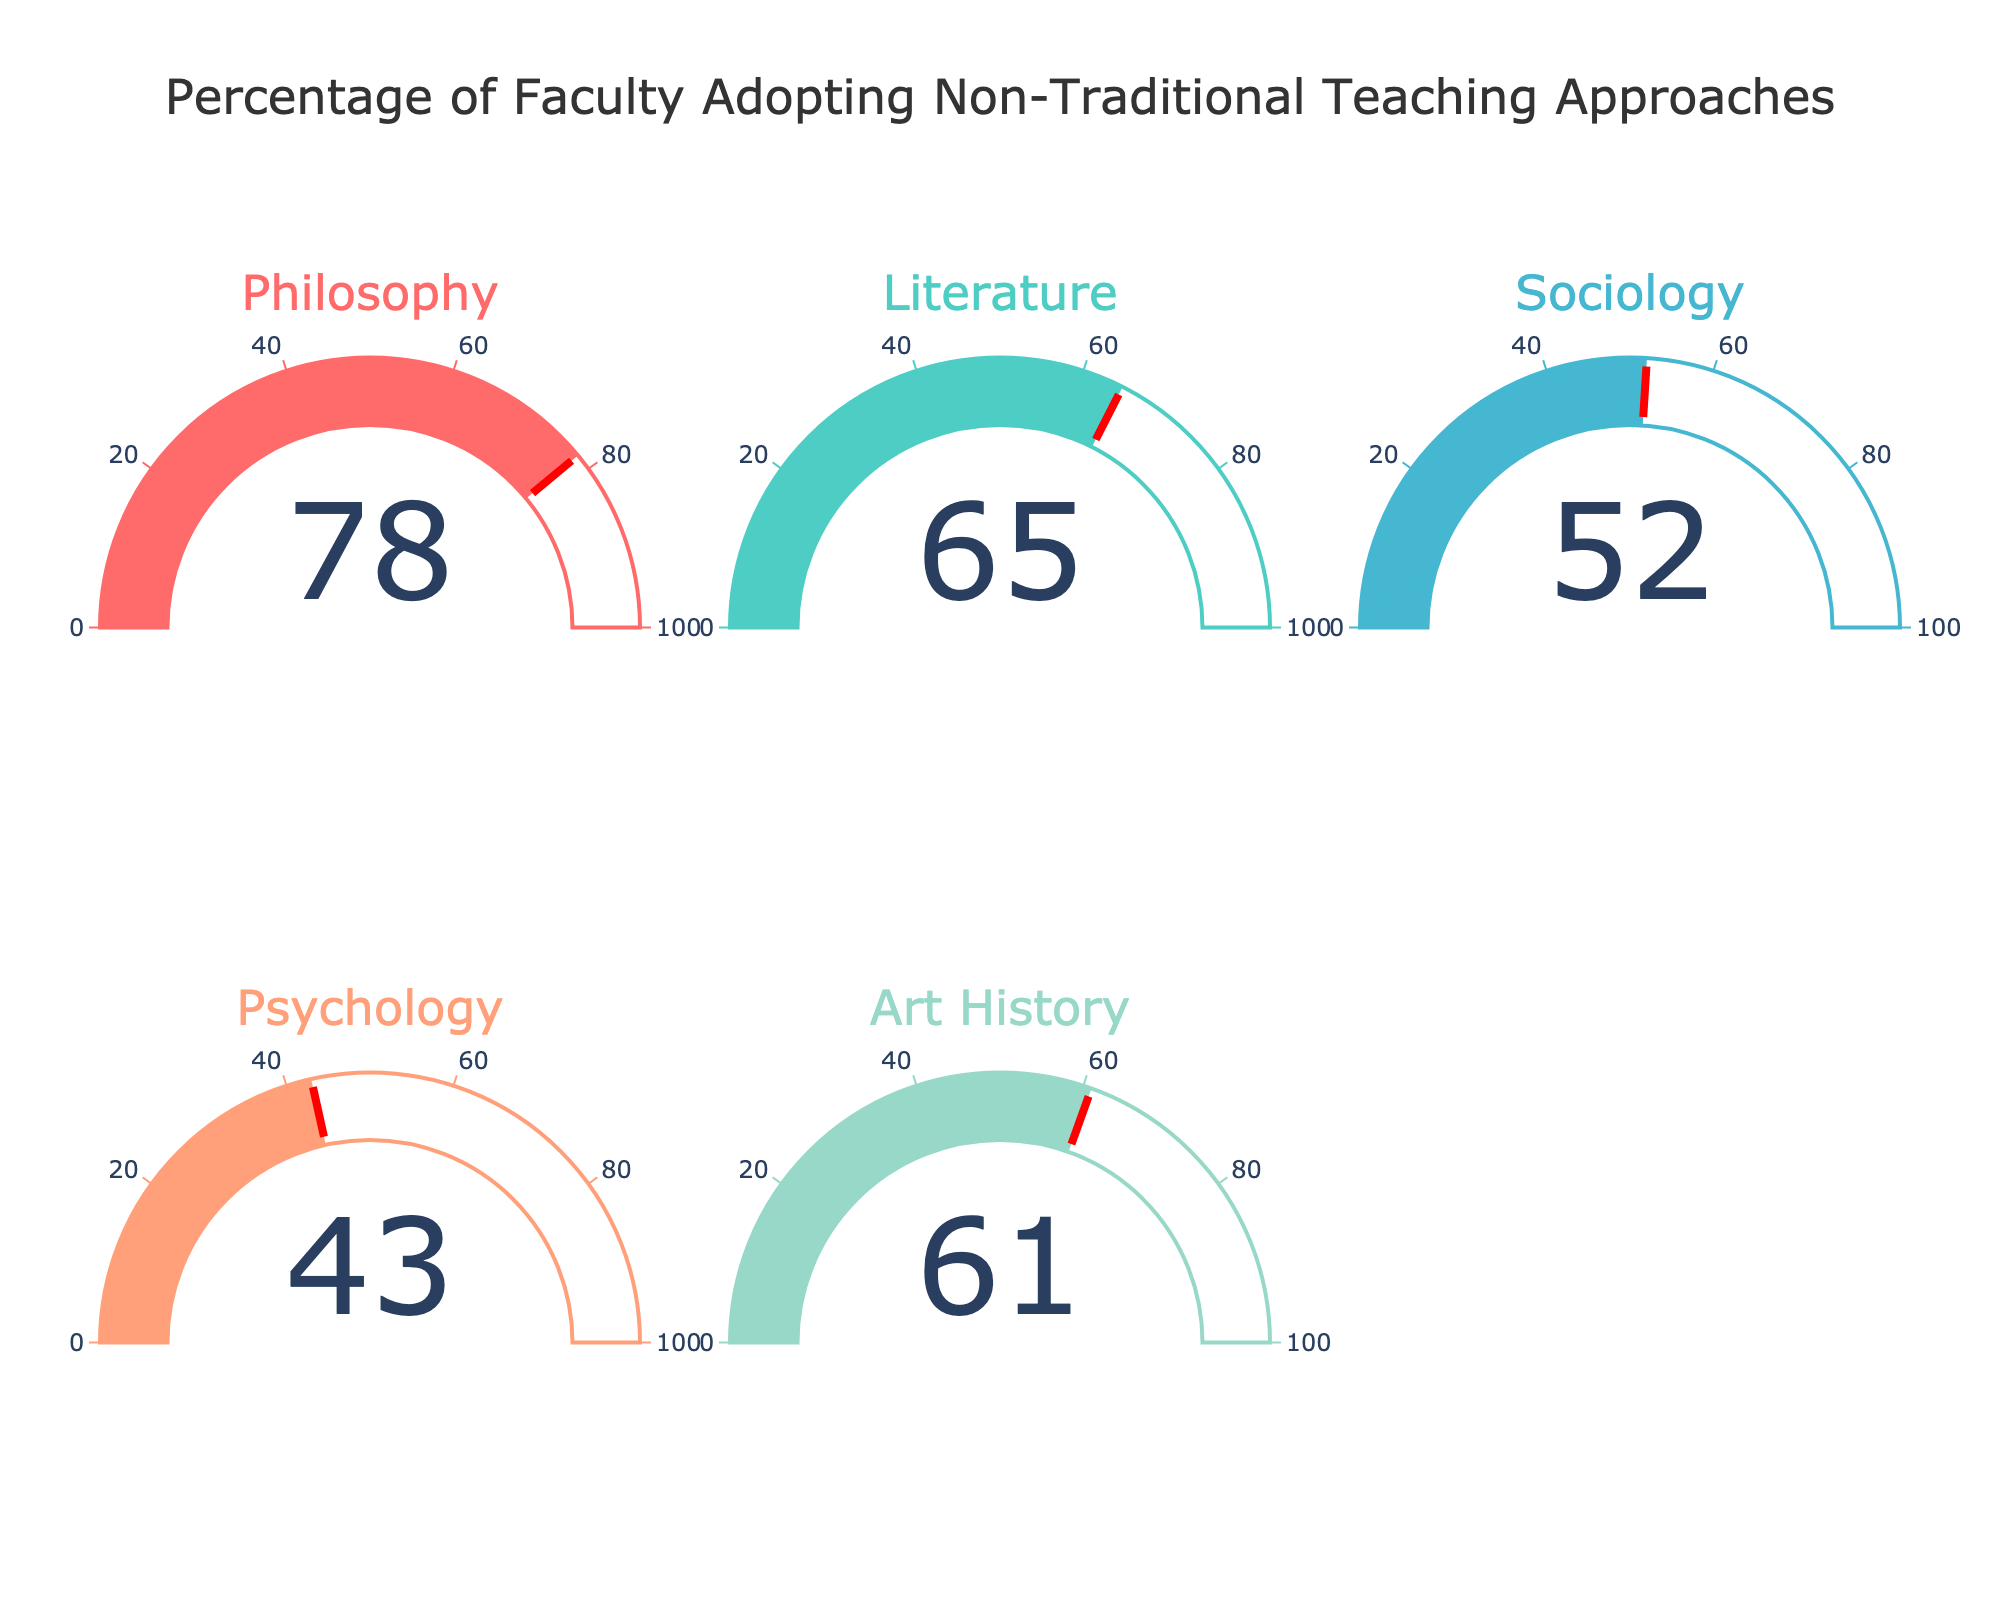What is the percentage of faculty adopting non-traditional teaching approaches in the Philosophy department? The gauge for the Philosophy department shows a percentage value, which is 78%.
Answer: 78% Which department has the highest percentage of faculty adopting non-traditional teaching approaches? To determine this, look at the value displayed on each gauge. The Philosophy department has the highest percentage at 78%.
Answer: Philosophy Which department has the lowest percentage of faculty adopting non-traditional teaching approaches? To find the lowest percentage, compare the values on each gauge. The Psychology department shows the lowest percentage at 43%.
Answer: Psychology What is the average percentage of faculty adopting non-traditional teaching approaches across all departments? Add the percentages from all the departments and divide by the number of departments. (78 + 65 + 52 + 43 + 61) / 5 = 59.8%
Answer: 59.8% What is the difference in the percentage of faculty adopting non-traditional teaching approaches between the Philosophy and Psychology departments? Subtract the percentage of the Psychology department from the Philosophy department. 78 - 43 = 35%
Answer: 35% How does the adoption rate in the Literature department compare to the Art History department? Compare the values directly: 65% for Literature and 61% for Art History. Literature has a slightly higher rate.
Answer: Literature Are there more departments with percentages above 50% or below 50%? Count the number of departments with percentages above and below 50%. There are four departments above 50% (Philosophy, Literature, Sociology, Art History) and one below 50% (Psychology).
Answer: Above 50% Which two departments have the closest percentages of faculty adopting non-traditional teaching approaches? Look for the smallest difference between percentages. Literature (65%) and Art History (61%) have the closest percentages with a difference of 4%.
Answer: Literature and Art History 